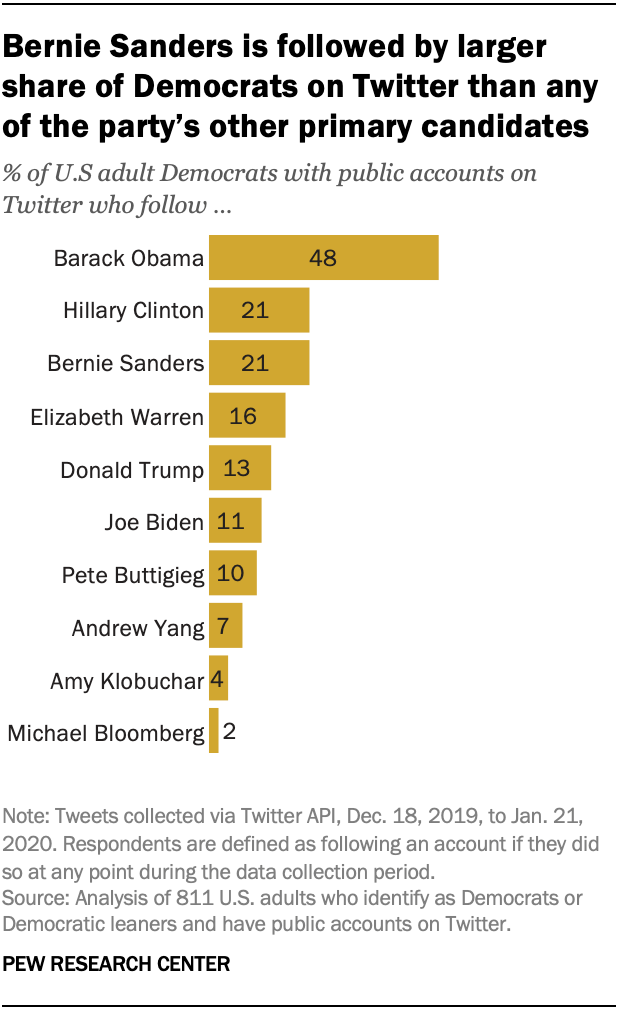Indicate a few pertinent items in this graphic. The median of all the bars is not greater than the average of all the bars. The second bar from the bottom has a value of 4. 